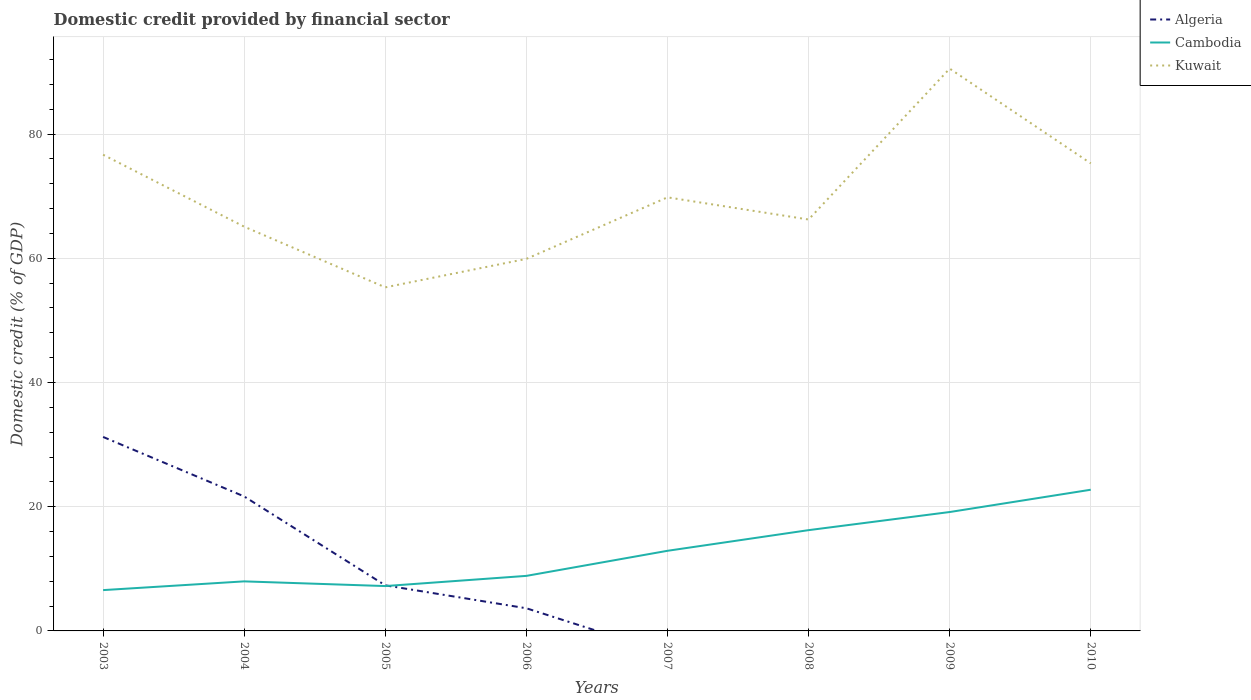How many different coloured lines are there?
Ensure brevity in your answer.  3. Does the line corresponding to Algeria intersect with the line corresponding to Cambodia?
Give a very brief answer. Yes. Is the number of lines equal to the number of legend labels?
Keep it short and to the point. No. Across all years, what is the maximum domestic credit in Kuwait?
Your answer should be very brief. 55.32. What is the total domestic credit in Kuwait in the graph?
Your answer should be very brief. -4.59. What is the difference between the highest and the second highest domestic credit in Algeria?
Give a very brief answer. 31.24. Does the graph contain grids?
Ensure brevity in your answer.  Yes. How are the legend labels stacked?
Your response must be concise. Vertical. What is the title of the graph?
Provide a short and direct response. Domestic credit provided by financial sector. What is the label or title of the Y-axis?
Your answer should be compact. Domestic credit (% of GDP). What is the Domestic credit (% of GDP) in Algeria in 2003?
Offer a terse response. 31.24. What is the Domestic credit (% of GDP) of Cambodia in 2003?
Give a very brief answer. 6.57. What is the Domestic credit (% of GDP) of Kuwait in 2003?
Offer a terse response. 76.68. What is the Domestic credit (% of GDP) of Algeria in 2004?
Your answer should be very brief. 21.65. What is the Domestic credit (% of GDP) in Cambodia in 2004?
Your answer should be compact. 7.98. What is the Domestic credit (% of GDP) in Kuwait in 2004?
Give a very brief answer. 65.09. What is the Domestic credit (% of GDP) of Algeria in 2005?
Your answer should be compact. 7.34. What is the Domestic credit (% of GDP) of Cambodia in 2005?
Provide a succinct answer. 7.22. What is the Domestic credit (% of GDP) in Kuwait in 2005?
Provide a succinct answer. 55.32. What is the Domestic credit (% of GDP) of Algeria in 2006?
Your answer should be compact. 3.65. What is the Domestic credit (% of GDP) of Cambodia in 2006?
Keep it short and to the point. 8.86. What is the Domestic credit (% of GDP) of Kuwait in 2006?
Give a very brief answer. 59.91. What is the Domestic credit (% of GDP) in Cambodia in 2007?
Provide a short and direct response. 12.9. What is the Domestic credit (% of GDP) of Kuwait in 2007?
Your answer should be very brief. 69.82. What is the Domestic credit (% of GDP) of Cambodia in 2008?
Ensure brevity in your answer.  16.23. What is the Domestic credit (% of GDP) in Kuwait in 2008?
Ensure brevity in your answer.  66.25. What is the Domestic credit (% of GDP) in Algeria in 2009?
Keep it short and to the point. 0. What is the Domestic credit (% of GDP) of Cambodia in 2009?
Your answer should be very brief. 19.14. What is the Domestic credit (% of GDP) in Kuwait in 2009?
Ensure brevity in your answer.  90.54. What is the Domestic credit (% of GDP) of Cambodia in 2010?
Your answer should be compact. 22.74. What is the Domestic credit (% of GDP) in Kuwait in 2010?
Give a very brief answer. 75.28. Across all years, what is the maximum Domestic credit (% of GDP) of Algeria?
Give a very brief answer. 31.24. Across all years, what is the maximum Domestic credit (% of GDP) in Cambodia?
Provide a succinct answer. 22.74. Across all years, what is the maximum Domestic credit (% of GDP) of Kuwait?
Keep it short and to the point. 90.54. Across all years, what is the minimum Domestic credit (% of GDP) in Algeria?
Give a very brief answer. 0. Across all years, what is the minimum Domestic credit (% of GDP) in Cambodia?
Provide a succinct answer. 6.57. Across all years, what is the minimum Domestic credit (% of GDP) in Kuwait?
Your answer should be compact. 55.32. What is the total Domestic credit (% of GDP) of Algeria in the graph?
Make the answer very short. 63.87. What is the total Domestic credit (% of GDP) in Cambodia in the graph?
Ensure brevity in your answer.  101.65. What is the total Domestic credit (% of GDP) in Kuwait in the graph?
Provide a short and direct response. 558.88. What is the difference between the Domestic credit (% of GDP) in Algeria in 2003 and that in 2004?
Ensure brevity in your answer.  9.58. What is the difference between the Domestic credit (% of GDP) of Cambodia in 2003 and that in 2004?
Your response must be concise. -1.41. What is the difference between the Domestic credit (% of GDP) in Kuwait in 2003 and that in 2004?
Offer a terse response. 11.59. What is the difference between the Domestic credit (% of GDP) in Algeria in 2003 and that in 2005?
Ensure brevity in your answer.  23.9. What is the difference between the Domestic credit (% of GDP) in Cambodia in 2003 and that in 2005?
Offer a very short reply. -0.65. What is the difference between the Domestic credit (% of GDP) in Kuwait in 2003 and that in 2005?
Make the answer very short. 21.36. What is the difference between the Domestic credit (% of GDP) in Algeria in 2003 and that in 2006?
Offer a terse response. 27.59. What is the difference between the Domestic credit (% of GDP) in Cambodia in 2003 and that in 2006?
Your response must be concise. -2.29. What is the difference between the Domestic credit (% of GDP) in Kuwait in 2003 and that in 2006?
Make the answer very short. 16.77. What is the difference between the Domestic credit (% of GDP) of Cambodia in 2003 and that in 2007?
Give a very brief answer. -6.33. What is the difference between the Domestic credit (% of GDP) of Kuwait in 2003 and that in 2007?
Your answer should be very brief. 6.86. What is the difference between the Domestic credit (% of GDP) of Cambodia in 2003 and that in 2008?
Your answer should be compact. -9.66. What is the difference between the Domestic credit (% of GDP) in Kuwait in 2003 and that in 2008?
Make the answer very short. 10.43. What is the difference between the Domestic credit (% of GDP) in Cambodia in 2003 and that in 2009?
Give a very brief answer. -12.57. What is the difference between the Domestic credit (% of GDP) of Kuwait in 2003 and that in 2009?
Offer a terse response. -13.86. What is the difference between the Domestic credit (% of GDP) in Cambodia in 2003 and that in 2010?
Your answer should be compact. -16.16. What is the difference between the Domestic credit (% of GDP) in Kuwait in 2003 and that in 2010?
Ensure brevity in your answer.  1.39. What is the difference between the Domestic credit (% of GDP) in Algeria in 2004 and that in 2005?
Your answer should be compact. 14.31. What is the difference between the Domestic credit (% of GDP) of Cambodia in 2004 and that in 2005?
Offer a very short reply. 0.76. What is the difference between the Domestic credit (% of GDP) in Kuwait in 2004 and that in 2005?
Your answer should be compact. 9.77. What is the difference between the Domestic credit (% of GDP) in Algeria in 2004 and that in 2006?
Your answer should be very brief. 18. What is the difference between the Domestic credit (% of GDP) in Cambodia in 2004 and that in 2006?
Offer a very short reply. -0.88. What is the difference between the Domestic credit (% of GDP) in Kuwait in 2004 and that in 2006?
Your response must be concise. 5.18. What is the difference between the Domestic credit (% of GDP) of Cambodia in 2004 and that in 2007?
Provide a short and direct response. -4.92. What is the difference between the Domestic credit (% of GDP) in Kuwait in 2004 and that in 2007?
Provide a succinct answer. -4.72. What is the difference between the Domestic credit (% of GDP) of Cambodia in 2004 and that in 2008?
Ensure brevity in your answer.  -8.25. What is the difference between the Domestic credit (% of GDP) of Kuwait in 2004 and that in 2008?
Your answer should be compact. -1.15. What is the difference between the Domestic credit (% of GDP) of Cambodia in 2004 and that in 2009?
Provide a succinct answer. -11.17. What is the difference between the Domestic credit (% of GDP) of Kuwait in 2004 and that in 2009?
Keep it short and to the point. -25.45. What is the difference between the Domestic credit (% of GDP) in Cambodia in 2004 and that in 2010?
Offer a very short reply. -14.76. What is the difference between the Domestic credit (% of GDP) in Kuwait in 2004 and that in 2010?
Ensure brevity in your answer.  -10.19. What is the difference between the Domestic credit (% of GDP) of Algeria in 2005 and that in 2006?
Offer a very short reply. 3.69. What is the difference between the Domestic credit (% of GDP) of Cambodia in 2005 and that in 2006?
Provide a succinct answer. -1.64. What is the difference between the Domestic credit (% of GDP) in Kuwait in 2005 and that in 2006?
Keep it short and to the point. -4.59. What is the difference between the Domestic credit (% of GDP) in Cambodia in 2005 and that in 2007?
Offer a very short reply. -5.68. What is the difference between the Domestic credit (% of GDP) in Kuwait in 2005 and that in 2007?
Offer a very short reply. -14.49. What is the difference between the Domestic credit (% of GDP) in Cambodia in 2005 and that in 2008?
Your answer should be compact. -9. What is the difference between the Domestic credit (% of GDP) in Kuwait in 2005 and that in 2008?
Offer a very short reply. -10.92. What is the difference between the Domestic credit (% of GDP) in Cambodia in 2005 and that in 2009?
Offer a terse response. -11.92. What is the difference between the Domestic credit (% of GDP) of Kuwait in 2005 and that in 2009?
Your response must be concise. -35.22. What is the difference between the Domestic credit (% of GDP) in Cambodia in 2005 and that in 2010?
Offer a terse response. -15.51. What is the difference between the Domestic credit (% of GDP) of Kuwait in 2005 and that in 2010?
Your response must be concise. -19.96. What is the difference between the Domestic credit (% of GDP) of Cambodia in 2006 and that in 2007?
Offer a very short reply. -4.04. What is the difference between the Domestic credit (% of GDP) in Kuwait in 2006 and that in 2007?
Ensure brevity in your answer.  -9.91. What is the difference between the Domestic credit (% of GDP) of Cambodia in 2006 and that in 2008?
Keep it short and to the point. -7.36. What is the difference between the Domestic credit (% of GDP) of Kuwait in 2006 and that in 2008?
Your response must be concise. -6.34. What is the difference between the Domestic credit (% of GDP) of Cambodia in 2006 and that in 2009?
Give a very brief answer. -10.28. What is the difference between the Domestic credit (% of GDP) in Kuwait in 2006 and that in 2009?
Your answer should be very brief. -30.63. What is the difference between the Domestic credit (% of GDP) in Cambodia in 2006 and that in 2010?
Offer a very short reply. -13.87. What is the difference between the Domestic credit (% of GDP) in Kuwait in 2006 and that in 2010?
Provide a short and direct response. -15.38. What is the difference between the Domestic credit (% of GDP) of Cambodia in 2007 and that in 2008?
Give a very brief answer. -3.33. What is the difference between the Domestic credit (% of GDP) of Kuwait in 2007 and that in 2008?
Offer a very short reply. 3.57. What is the difference between the Domestic credit (% of GDP) of Cambodia in 2007 and that in 2009?
Provide a succinct answer. -6.24. What is the difference between the Domestic credit (% of GDP) in Kuwait in 2007 and that in 2009?
Your response must be concise. -20.72. What is the difference between the Domestic credit (% of GDP) of Cambodia in 2007 and that in 2010?
Offer a very short reply. -9.83. What is the difference between the Domestic credit (% of GDP) in Kuwait in 2007 and that in 2010?
Your response must be concise. -5.47. What is the difference between the Domestic credit (% of GDP) of Cambodia in 2008 and that in 2009?
Offer a terse response. -2.92. What is the difference between the Domestic credit (% of GDP) in Kuwait in 2008 and that in 2009?
Your response must be concise. -24.3. What is the difference between the Domestic credit (% of GDP) in Cambodia in 2008 and that in 2010?
Provide a short and direct response. -6.51. What is the difference between the Domestic credit (% of GDP) of Kuwait in 2008 and that in 2010?
Offer a terse response. -9.04. What is the difference between the Domestic credit (% of GDP) of Cambodia in 2009 and that in 2010?
Offer a terse response. -3.59. What is the difference between the Domestic credit (% of GDP) in Kuwait in 2009 and that in 2010?
Provide a short and direct response. 15.26. What is the difference between the Domestic credit (% of GDP) of Algeria in 2003 and the Domestic credit (% of GDP) of Cambodia in 2004?
Ensure brevity in your answer.  23.26. What is the difference between the Domestic credit (% of GDP) of Algeria in 2003 and the Domestic credit (% of GDP) of Kuwait in 2004?
Keep it short and to the point. -33.86. What is the difference between the Domestic credit (% of GDP) of Cambodia in 2003 and the Domestic credit (% of GDP) of Kuwait in 2004?
Your response must be concise. -58.52. What is the difference between the Domestic credit (% of GDP) of Algeria in 2003 and the Domestic credit (% of GDP) of Cambodia in 2005?
Offer a terse response. 24.01. What is the difference between the Domestic credit (% of GDP) of Algeria in 2003 and the Domestic credit (% of GDP) of Kuwait in 2005?
Offer a very short reply. -24.09. What is the difference between the Domestic credit (% of GDP) of Cambodia in 2003 and the Domestic credit (% of GDP) of Kuwait in 2005?
Make the answer very short. -48.75. What is the difference between the Domestic credit (% of GDP) of Algeria in 2003 and the Domestic credit (% of GDP) of Cambodia in 2006?
Give a very brief answer. 22.37. What is the difference between the Domestic credit (% of GDP) of Algeria in 2003 and the Domestic credit (% of GDP) of Kuwait in 2006?
Your response must be concise. -28.67. What is the difference between the Domestic credit (% of GDP) in Cambodia in 2003 and the Domestic credit (% of GDP) in Kuwait in 2006?
Ensure brevity in your answer.  -53.34. What is the difference between the Domestic credit (% of GDP) of Algeria in 2003 and the Domestic credit (% of GDP) of Cambodia in 2007?
Your response must be concise. 18.33. What is the difference between the Domestic credit (% of GDP) of Algeria in 2003 and the Domestic credit (% of GDP) of Kuwait in 2007?
Provide a short and direct response. -38.58. What is the difference between the Domestic credit (% of GDP) of Cambodia in 2003 and the Domestic credit (% of GDP) of Kuwait in 2007?
Offer a very short reply. -63.24. What is the difference between the Domestic credit (% of GDP) of Algeria in 2003 and the Domestic credit (% of GDP) of Cambodia in 2008?
Your answer should be very brief. 15.01. What is the difference between the Domestic credit (% of GDP) in Algeria in 2003 and the Domestic credit (% of GDP) in Kuwait in 2008?
Your answer should be compact. -35.01. What is the difference between the Domestic credit (% of GDP) in Cambodia in 2003 and the Domestic credit (% of GDP) in Kuwait in 2008?
Your response must be concise. -59.67. What is the difference between the Domestic credit (% of GDP) in Algeria in 2003 and the Domestic credit (% of GDP) in Cambodia in 2009?
Offer a terse response. 12.09. What is the difference between the Domestic credit (% of GDP) of Algeria in 2003 and the Domestic credit (% of GDP) of Kuwait in 2009?
Offer a terse response. -59.31. What is the difference between the Domestic credit (% of GDP) of Cambodia in 2003 and the Domestic credit (% of GDP) of Kuwait in 2009?
Your answer should be very brief. -83.97. What is the difference between the Domestic credit (% of GDP) of Algeria in 2003 and the Domestic credit (% of GDP) of Cambodia in 2010?
Your response must be concise. 8.5. What is the difference between the Domestic credit (% of GDP) of Algeria in 2003 and the Domestic credit (% of GDP) of Kuwait in 2010?
Your response must be concise. -44.05. What is the difference between the Domestic credit (% of GDP) in Cambodia in 2003 and the Domestic credit (% of GDP) in Kuwait in 2010?
Your response must be concise. -68.71. What is the difference between the Domestic credit (% of GDP) of Algeria in 2004 and the Domestic credit (% of GDP) of Cambodia in 2005?
Ensure brevity in your answer.  14.43. What is the difference between the Domestic credit (% of GDP) in Algeria in 2004 and the Domestic credit (% of GDP) in Kuwait in 2005?
Your answer should be compact. -33.67. What is the difference between the Domestic credit (% of GDP) in Cambodia in 2004 and the Domestic credit (% of GDP) in Kuwait in 2005?
Offer a very short reply. -47.34. What is the difference between the Domestic credit (% of GDP) in Algeria in 2004 and the Domestic credit (% of GDP) in Cambodia in 2006?
Your answer should be very brief. 12.79. What is the difference between the Domestic credit (% of GDP) in Algeria in 2004 and the Domestic credit (% of GDP) in Kuwait in 2006?
Provide a short and direct response. -38.26. What is the difference between the Domestic credit (% of GDP) of Cambodia in 2004 and the Domestic credit (% of GDP) of Kuwait in 2006?
Make the answer very short. -51.93. What is the difference between the Domestic credit (% of GDP) of Algeria in 2004 and the Domestic credit (% of GDP) of Cambodia in 2007?
Offer a terse response. 8.75. What is the difference between the Domestic credit (% of GDP) of Algeria in 2004 and the Domestic credit (% of GDP) of Kuwait in 2007?
Offer a terse response. -48.16. What is the difference between the Domestic credit (% of GDP) in Cambodia in 2004 and the Domestic credit (% of GDP) in Kuwait in 2007?
Keep it short and to the point. -61.84. What is the difference between the Domestic credit (% of GDP) in Algeria in 2004 and the Domestic credit (% of GDP) in Cambodia in 2008?
Your answer should be compact. 5.42. What is the difference between the Domestic credit (% of GDP) in Algeria in 2004 and the Domestic credit (% of GDP) in Kuwait in 2008?
Keep it short and to the point. -44.59. What is the difference between the Domestic credit (% of GDP) of Cambodia in 2004 and the Domestic credit (% of GDP) of Kuwait in 2008?
Your response must be concise. -58.27. What is the difference between the Domestic credit (% of GDP) of Algeria in 2004 and the Domestic credit (% of GDP) of Cambodia in 2009?
Provide a succinct answer. 2.51. What is the difference between the Domestic credit (% of GDP) of Algeria in 2004 and the Domestic credit (% of GDP) of Kuwait in 2009?
Provide a short and direct response. -68.89. What is the difference between the Domestic credit (% of GDP) in Cambodia in 2004 and the Domestic credit (% of GDP) in Kuwait in 2009?
Ensure brevity in your answer.  -82.56. What is the difference between the Domestic credit (% of GDP) of Algeria in 2004 and the Domestic credit (% of GDP) of Cambodia in 2010?
Your response must be concise. -1.08. What is the difference between the Domestic credit (% of GDP) of Algeria in 2004 and the Domestic credit (% of GDP) of Kuwait in 2010?
Offer a terse response. -53.63. What is the difference between the Domestic credit (% of GDP) of Cambodia in 2004 and the Domestic credit (% of GDP) of Kuwait in 2010?
Provide a short and direct response. -67.31. What is the difference between the Domestic credit (% of GDP) in Algeria in 2005 and the Domestic credit (% of GDP) in Cambodia in 2006?
Keep it short and to the point. -1.53. What is the difference between the Domestic credit (% of GDP) in Algeria in 2005 and the Domestic credit (% of GDP) in Kuwait in 2006?
Make the answer very short. -52.57. What is the difference between the Domestic credit (% of GDP) of Cambodia in 2005 and the Domestic credit (% of GDP) of Kuwait in 2006?
Offer a very short reply. -52.68. What is the difference between the Domestic credit (% of GDP) in Algeria in 2005 and the Domestic credit (% of GDP) in Cambodia in 2007?
Ensure brevity in your answer.  -5.56. What is the difference between the Domestic credit (% of GDP) in Algeria in 2005 and the Domestic credit (% of GDP) in Kuwait in 2007?
Provide a short and direct response. -62.48. What is the difference between the Domestic credit (% of GDP) in Cambodia in 2005 and the Domestic credit (% of GDP) in Kuwait in 2007?
Keep it short and to the point. -62.59. What is the difference between the Domestic credit (% of GDP) of Algeria in 2005 and the Domestic credit (% of GDP) of Cambodia in 2008?
Give a very brief answer. -8.89. What is the difference between the Domestic credit (% of GDP) of Algeria in 2005 and the Domestic credit (% of GDP) of Kuwait in 2008?
Your response must be concise. -58.91. What is the difference between the Domestic credit (% of GDP) of Cambodia in 2005 and the Domestic credit (% of GDP) of Kuwait in 2008?
Offer a very short reply. -59.02. What is the difference between the Domestic credit (% of GDP) in Algeria in 2005 and the Domestic credit (% of GDP) in Cambodia in 2009?
Ensure brevity in your answer.  -11.81. What is the difference between the Domestic credit (% of GDP) in Algeria in 2005 and the Domestic credit (% of GDP) in Kuwait in 2009?
Ensure brevity in your answer.  -83.2. What is the difference between the Domestic credit (% of GDP) of Cambodia in 2005 and the Domestic credit (% of GDP) of Kuwait in 2009?
Ensure brevity in your answer.  -83.32. What is the difference between the Domestic credit (% of GDP) of Algeria in 2005 and the Domestic credit (% of GDP) of Cambodia in 2010?
Keep it short and to the point. -15.4. What is the difference between the Domestic credit (% of GDP) of Algeria in 2005 and the Domestic credit (% of GDP) of Kuwait in 2010?
Keep it short and to the point. -67.95. What is the difference between the Domestic credit (% of GDP) in Cambodia in 2005 and the Domestic credit (% of GDP) in Kuwait in 2010?
Your response must be concise. -68.06. What is the difference between the Domestic credit (% of GDP) of Algeria in 2006 and the Domestic credit (% of GDP) of Cambodia in 2007?
Your answer should be very brief. -9.25. What is the difference between the Domestic credit (% of GDP) in Algeria in 2006 and the Domestic credit (% of GDP) in Kuwait in 2007?
Keep it short and to the point. -66.17. What is the difference between the Domestic credit (% of GDP) in Cambodia in 2006 and the Domestic credit (% of GDP) in Kuwait in 2007?
Provide a short and direct response. -60.95. What is the difference between the Domestic credit (% of GDP) of Algeria in 2006 and the Domestic credit (% of GDP) of Cambodia in 2008?
Your answer should be very brief. -12.58. What is the difference between the Domestic credit (% of GDP) in Algeria in 2006 and the Domestic credit (% of GDP) in Kuwait in 2008?
Make the answer very short. -62.6. What is the difference between the Domestic credit (% of GDP) of Cambodia in 2006 and the Domestic credit (% of GDP) of Kuwait in 2008?
Your answer should be very brief. -57.38. What is the difference between the Domestic credit (% of GDP) in Algeria in 2006 and the Domestic credit (% of GDP) in Cambodia in 2009?
Your response must be concise. -15.5. What is the difference between the Domestic credit (% of GDP) of Algeria in 2006 and the Domestic credit (% of GDP) of Kuwait in 2009?
Your answer should be compact. -86.89. What is the difference between the Domestic credit (% of GDP) of Cambodia in 2006 and the Domestic credit (% of GDP) of Kuwait in 2009?
Provide a short and direct response. -81.68. What is the difference between the Domestic credit (% of GDP) of Algeria in 2006 and the Domestic credit (% of GDP) of Cambodia in 2010?
Provide a short and direct response. -19.09. What is the difference between the Domestic credit (% of GDP) of Algeria in 2006 and the Domestic credit (% of GDP) of Kuwait in 2010?
Provide a succinct answer. -71.64. What is the difference between the Domestic credit (% of GDP) of Cambodia in 2006 and the Domestic credit (% of GDP) of Kuwait in 2010?
Offer a terse response. -66.42. What is the difference between the Domestic credit (% of GDP) of Cambodia in 2007 and the Domestic credit (% of GDP) of Kuwait in 2008?
Make the answer very short. -53.34. What is the difference between the Domestic credit (% of GDP) of Cambodia in 2007 and the Domestic credit (% of GDP) of Kuwait in 2009?
Your answer should be compact. -77.64. What is the difference between the Domestic credit (% of GDP) in Cambodia in 2007 and the Domestic credit (% of GDP) in Kuwait in 2010?
Keep it short and to the point. -62.38. What is the difference between the Domestic credit (% of GDP) in Cambodia in 2008 and the Domestic credit (% of GDP) in Kuwait in 2009?
Ensure brevity in your answer.  -74.31. What is the difference between the Domestic credit (% of GDP) in Cambodia in 2008 and the Domestic credit (% of GDP) in Kuwait in 2010?
Give a very brief answer. -59.06. What is the difference between the Domestic credit (% of GDP) in Cambodia in 2009 and the Domestic credit (% of GDP) in Kuwait in 2010?
Offer a very short reply. -56.14. What is the average Domestic credit (% of GDP) of Algeria per year?
Ensure brevity in your answer.  7.98. What is the average Domestic credit (% of GDP) of Cambodia per year?
Your answer should be very brief. 12.71. What is the average Domestic credit (% of GDP) of Kuwait per year?
Make the answer very short. 69.86. In the year 2003, what is the difference between the Domestic credit (% of GDP) in Algeria and Domestic credit (% of GDP) in Cambodia?
Offer a very short reply. 24.66. In the year 2003, what is the difference between the Domestic credit (% of GDP) of Algeria and Domestic credit (% of GDP) of Kuwait?
Your answer should be compact. -45.44. In the year 2003, what is the difference between the Domestic credit (% of GDP) in Cambodia and Domestic credit (% of GDP) in Kuwait?
Offer a terse response. -70.1. In the year 2004, what is the difference between the Domestic credit (% of GDP) in Algeria and Domestic credit (% of GDP) in Cambodia?
Provide a short and direct response. 13.67. In the year 2004, what is the difference between the Domestic credit (% of GDP) of Algeria and Domestic credit (% of GDP) of Kuwait?
Offer a very short reply. -43.44. In the year 2004, what is the difference between the Domestic credit (% of GDP) in Cambodia and Domestic credit (% of GDP) in Kuwait?
Give a very brief answer. -57.11. In the year 2005, what is the difference between the Domestic credit (% of GDP) of Algeria and Domestic credit (% of GDP) of Cambodia?
Your answer should be very brief. 0.11. In the year 2005, what is the difference between the Domestic credit (% of GDP) in Algeria and Domestic credit (% of GDP) in Kuwait?
Your answer should be very brief. -47.98. In the year 2005, what is the difference between the Domestic credit (% of GDP) in Cambodia and Domestic credit (% of GDP) in Kuwait?
Give a very brief answer. -48.1. In the year 2006, what is the difference between the Domestic credit (% of GDP) of Algeria and Domestic credit (% of GDP) of Cambodia?
Offer a very short reply. -5.22. In the year 2006, what is the difference between the Domestic credit (% of GDP) of Algeria and Domestic credit (% of GDP) of Kuwait?
Make the answer very short. -56.26. In the year 2006, what is the difference between the Domestic credit (% of GDP) in Cambodia and Domestic credit (% of GDP) in Kuwait?
Your response must be concise. -51.04. In the year 2007, what is the difference between the Domestic credit (% of GDP) of Cambodia and Domestic credit (% of GDP) of Kuwait?
Offer a very short reply. -56.91. In the year 2008, what is the difference between the Domestic credit (% of GDP) in Cambodia and Domestic credit (% of GDP) in Kuwait?
Your response must be concise. -50.02. In the year 2009, what is the difference between the Domestic credit (% of GDP) of Cambodia and Domestic credit (% of GDP) of Kuwait?
Your answer should be compact. -71.4. In the year 2010, what is the difference between the Domestic credit (% of GDP) in Cambodia and Domestic credit (% of GDP) in Kuwait?
Give a very brief answer. -52.55. What is the ratio of the Domestic credit (% of GDP) of Algeria in 2003 to that in 2004?
Offer a terse response. 1.44. What is the ratio of the Domestic credit (% of GDP) in Cambodia in 2003 to that in 2004?
Make the answer very short. 0.82. What is the ratio of the Domestic credit (% of GDP) of Kuwait in 2003 to that in 2004?
Your answer should be compact. 1.18. What is the ratio of the Domestic credit (% of GDP) of Algeria in 2003 to that in 2005?
Keep it short and to the point. 4.26. What is the ratio of the Domestic credit (% of GDP) of Cambodia in 2003 to that in 2005?
Make the answer very short. 0.91. What is the ratio of the Domestic credit (% of GDP) of Kuwait in 2003 to that in 2005?
Provide a succinct answer. 1.39. What is the ratio of the Domestic credit (% of GDP) in Algeria in 2003 to that in 2006?
Offer a terse response. 8.56. What is the ratio of the Domestic credit (% of GDP) in Cambodia in 2003 to that in 2006?
Your answer should be compact. 0.74. What is the ratio of the Domestic credit (% of GDP) in Kuwait in 2003 to that in 2006?
Provide a succinct answer. 1.28. What is the ratio of the Domestic credit (% of GDP) in Cambodia in 2003 to that in 2007?
Make the answer very short. 0.51. What is the ratio of the Domestic credit (% of GDP) in Kuwait in 2003 to that in 2007?
Make the answer very short. 1.1. What is the ratio of the Domestic credit (% of GDP) of Cambodia in 2003 to that in 2008?
Ensure brevity in your answer.  0.41. What is the ratio of the Domestic credit (% of GDP) in Kuwait in 2003 to that in 2008?
Your answer should be compact. 1.16. What is the ratio of the Domestic credit (% of GDP) of Cambodia in 2003 to that in 2009?
Your response must be concise. 0.34. What is the ratio of the Domestic credit (% of GDP) of Kuwait in 2003 to that in 2009?
Provide a short and direct response. 0.85. What is the ratio of the Domestic credit (% of GDP) of Cambodia in 2003 to that in 2010?
Your response must be concise. 0.29. What is the ratio of the Domestic credit (% of GDP) of Kuwait in 2003 to that in 2010?
Make the answer very short. 1.02. What is the ratio of the Domestic credit (% of GDP) of Algeria in 2004 to that in 2005?
Provide a succinct answer. 2.95. What is the ratio of the Domestic credit (% of GDP) of Cambodia in 2004 to that in 2005?
Your answer should be compact. 1.1. What is the ratio of the Domestic credit (% of GDP) of Kuwait in 2004 to that in 2005?
Offer a terse response. 1.18. What is the ratio of the Domestic credit (% of GDP) of Algeria in 2004 to that in 2006?
Your answer should be very brief. 5.93. What is the ratio of the Domestic credit (% of GDP) in Cambodia in 2004 to that in 2006?
Give a very brief answer. 0.9. What is the ratio of the Domestic credit (% of GDP) of Kuwait in 2004 to that in 2006?
Your answer should be very brief. 1.09. What is the ratio of the Domestic credit (% of GDP) of Cambodia in 2004 to that in 2007?
Offer a terse response. 0.62. What is the ratio of the Domestic credit (% of GDP) of Kuwait in 2004 to that in 2007?
Provide a short and direct response. 0.93. What is the ratio of the Domestic credit (% of GDP) of Cambodia in 2004 to that in 2008?
Provide a succinct answer. 0.49. What is the ratio of the Domestic credit (% of GDP) of Kuwait in 2004 to that in 2008?
Keep it short and to the point. 0.98. What is the ratio of the Domestic credit (% of GDP) in Cambodia in 2004 to that in 2009?
Your response must be concise. 0.42. What is the ratio of the Domestic credit (% of GDP) of Kuwait in 2004 to that in 2009?
Provide a short and direct response. 0.72. What is the ratio of the Domestic credit (% of GDP) of Cambodia in 2004 to that in 2010?
Your answer should be compact. 0.35. What is the ratio of the Domestic credit (% of GDP) in Kuwait in 2004 to that in 2010?
Offer a very short reply. 0.86. What is the ratio of the Domestic credit (% of GDP) of Algeria in 2005 to that in 2006?
Your answer should be very brief. 2.01. What is the ratio of the Domestic credit (% of GDP) of Cambodia in 2005 to that in 2006?
Provide a succinct answer. 0.81. What is the ratio of the Domestic credit (% of GDP) in Kuwait in 2005 to that in 2006?
Offer a very short reply. 0.92. What is the ratio of the Domestic credit (% of GDP) in Cambodia in 2005 to that in 2007?
Offer a terse response. 0.56. What is the ratio of the Domestic credit (% of GDP) of Kuwait in 2005 to that in 2007?
Your answer should be very brief. 0.79. What is the ratio of the Domestic credit (% of GDP) of Cambodia in 2005 to that in 2008?
Offer a terse response. 0.45. What is the ratio of the Domestic credit (% of GDP) in Kuwait in 2005 to that in 2008?
Make the answer very short. 0.84. What is the ratio of the Domestic credit (% of GDP) in Cambodia in 2005 to that in 2009?
Give a very brief answer. 0.38. What is the ratio of the Domestic credit (% of GDP) in Kuwait in 2005 to that in 2009?
Your response must be concise. 0.61. What is the ratio of the Domestic credit (% of GDP) in Cambodia in 2005 to that in 2010?
Offer a terse response. 0.32. What is the ratio of the Domestic credit (% of GDP) in Kuwait in 2005 to that in 2010?
Provide a short and direct response. 0.73. What is the ratio of the Domestic credit (% of GDP) of Cambodia in 2006 to that in 2007?
Your answer should be very brief. 0.69. What is the ratio of the Domestic credit (% of GDP) of Kuwait in 2006 to that in 2007?
Ensure brevity in your answer.  0.86. What is the ratio of the Domestic credit (% of GDP) of Cambodia in 2006 to that in 2008?
Offer a terse response. 0.55. What is the ratio of the Domestic credit (% of GDP) of Kuwait in 2006 to that in 2008?
Give a very brief answer. 0.9. What is the ratio of the Domestic credit (% of GDP) in Cambodia in 2006 to that in 2009?
Your answer should be compact. 0.46. What is the ratio of the Domestic credit (% of GDP) of Kuwait in 2006 to that in 2009?
Your answer should be very brief. 0.66. What is the ratio of the Domestic credit (% of GDP) of Cambodia in 2006 to that in 2010?
Give a very brief answer. 0.39. What is the ratio of the Domestic credit (% of GDP) in Kuwait in 2006 to that in 2010?
Make the answer very short. 0.8. What is the ratio of the Domestic credit (% of GDP) in Cambodia in 2007 to that in 2008?
Make the answer very short. 0.8. What is the ratio of the Domestic credit (% of GDP) in Kuwait in 2007 to that in 2008?
Give a very brief answer. 1.05. What is the ratio of the Domestic credit (% of GDP) in Cambodia in 2007 to that in 2009?
Offer a very short reply. 0.67. What is the ratio of the Domestic credit (% of GDP) of Kuwait in 2007 to that in 2009?
Keep it short and to the point. 0.77. What is the ratio of the Domestic credit (% of GDP) in Cambodia in 2007 to that in 2010?
Your answer should be compact. 0.57. What is the ratio of the Domestic credit (% of GDP) in Kuwait in 2007 to that in 2010?
Your answer should be very brief. 0.93. What is the ratio of the Domestic credit (% of GDP) of Cambodia in 2008 to that in 2009?
Give a very brief answer. 0.85. What is the ratio of the Domestic credit (% of GDP) in Kuwait in 2008 to that in 2009?
Provide a short and direct response. 0.73. What is the ratio of the Domestic credit (% of GDP) of Cambodia in 2008 to that in 2010?
Provide a short and direct response. 0.71. What is the ratio of the Domestic credit (% of GDP) of Kuwait in 2008 to that in 2010?
Your response must be concise. 0.88. What is the ratio of the Domestic credit (% of GDP) of Cambodia in 2009 to that in 2010?
Give a very brief answer. 0.84. What is the ratio of the Domestic credit (% of GDP) of Kuwait in 2009 to that in 2010?
Offer a terse response. 1.2. What is the difference between the highest and the second highest Domestic credit (% of GDP) of Algeria?
Ensure brevity in your answer.  9.58. What is the difference between the highest and the second highest Domestic credit (% of GDP) in Cambodia?
Make the answer very short. 3.59. What is the difference between the highest and the second highest Domestic credit (% of GDP) of Kuwait?
Your answer should be very brief. 13.86. What is the difference between the highest and the lowest Domestic credit (% of GDP) in Algeria?
Provide a succinct answer. 31.24. What is the difference between the highest and the lowest Domestic credit (% of GDP) of Cambodia?
Your answer should be very brief. 16.16. What is the difference between the highest and the lowest Domestic credit (% of GDP) of Kuwait?
Give a very brief answer. 35.22. 